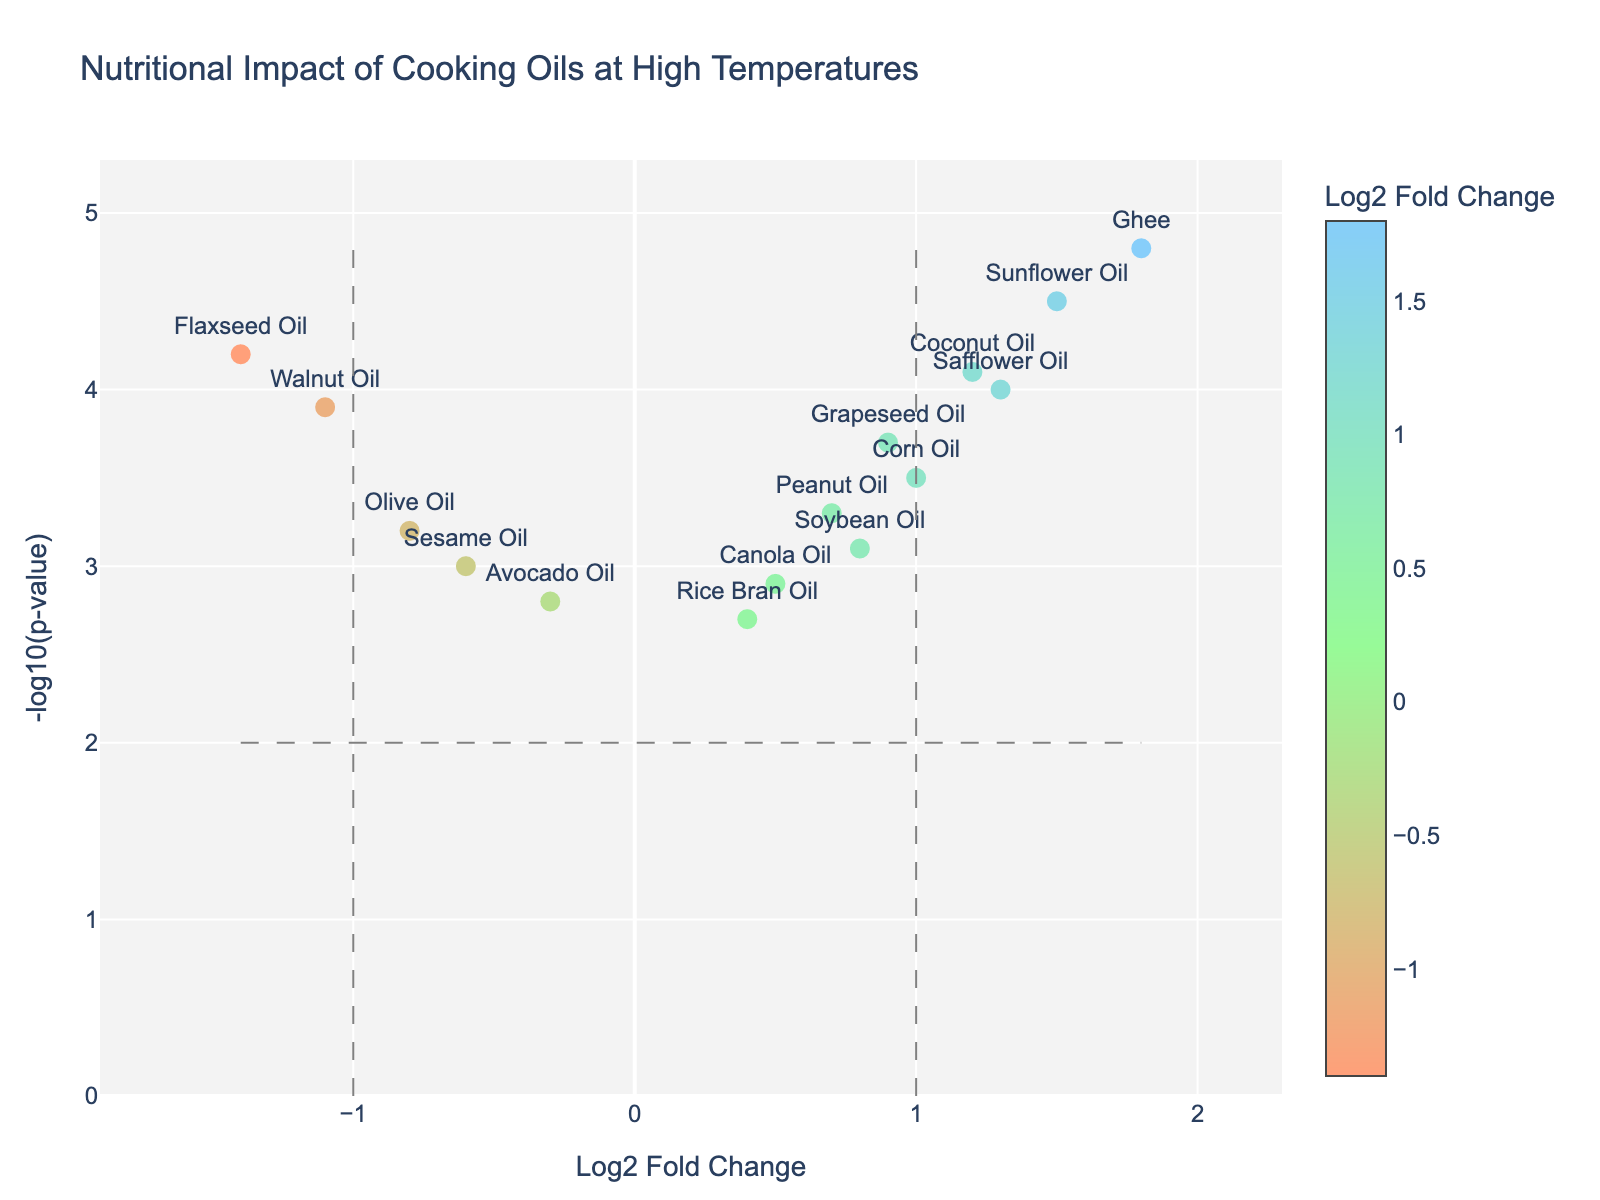What is the title of the plot? The title of the plot is usually found at the top of the figure. It gives an overview of what the plot is about.
Answer: Nutritional Impact of Cooking Oils at High Temperatures What are the x-axis and y-axis titles of the plot? The x-axis and y-axis titles describe what each axis represents in the plot. You can find them next to their respective axes.
Answer: Log2 Fold Change and -log10(p-value) How many data points are displayed in the figure? The number of data points corresponds to the number of oils listed. You can count the markers in the plot.
Answer: 15 Which oil has the highest negative Log2FoldChange? To find the oil with the highest negative Log2FoldChange, look for the marker furthest to the left on the x-axis.
Answer: Flaxseed Oil Which oil is positioned the highest on the y-axis? To find the oil positioned the highest on the y-axis, look for the marker placed at the highest -log10(p-value).
Answer: Ghee How many oils have a Log2FoldChange greater than 1? To find oils with Log2FoldChange greater than 1, count the markers to the right of the vertical line at x=1.
Answer: 4 Which two oils have the closest Log2FoldChange values? To find the oils with the closest Log2FoldChange values, compare the x-axis positions of the markers and identify the smallest distance between them.
Answer: Soybean Oil and Peanut Oil How many oils have a NegativeLog10PValue greater than 4? To find the oils with a NegativeLog10PValue greater than 4, count the markers above the horizontal line at y=4.
Answer: 5 Which oils are considered significantly different based on the plot lines? Oils with Log2FoldChange greater than 1 or less than -1 and NegativeLog10PValue greater than 2 are considered significant. Look at markers beyond these lines.
Answer: Coconut Oil, Sunflower Oil, Ghee, Safflower Oil, Walnut Oil, Flaxseed Oil 